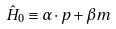Convert formula to latex. <formula><loc_0><loc_0><loc_500><loc_500>\hat { H } _ { 0 } \equiv \alpha \cdot p + \beta m</formula> 